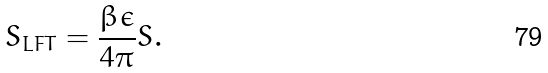Convert formula to latex. <formula><loc_0><loc_0><loc_500><loc_500>S _ { L F T } = \frac { \beta \epsilon } { 4 \pi } S .</formula> 